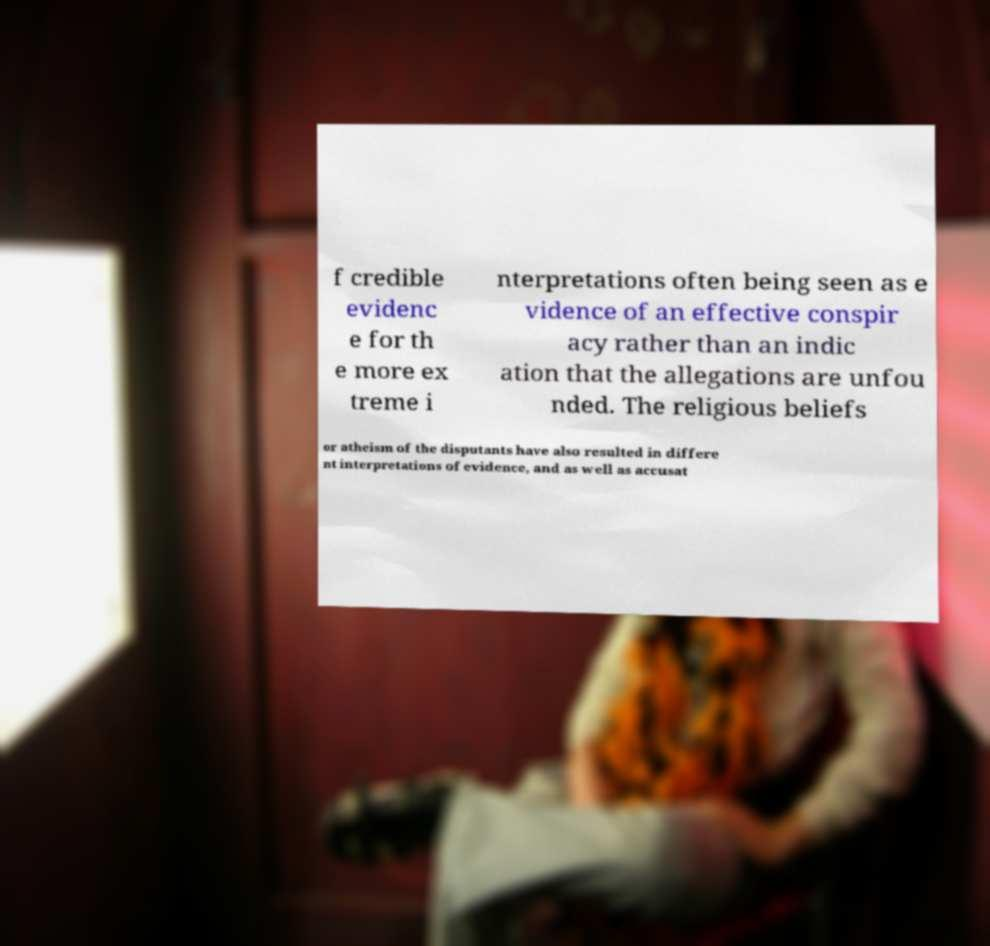Could you assist in decoding the text presented in this image and type it out clearly? f credible evidenc e for th e more ex treme i nterpretations often being seen as e vidence of an effective conspir acy rather than an indic ation that the allegations are unfou nded. The religious beliefs or atheism of the disputants have also resulted in differe nt interpretations of evidence, and as well as accusat 